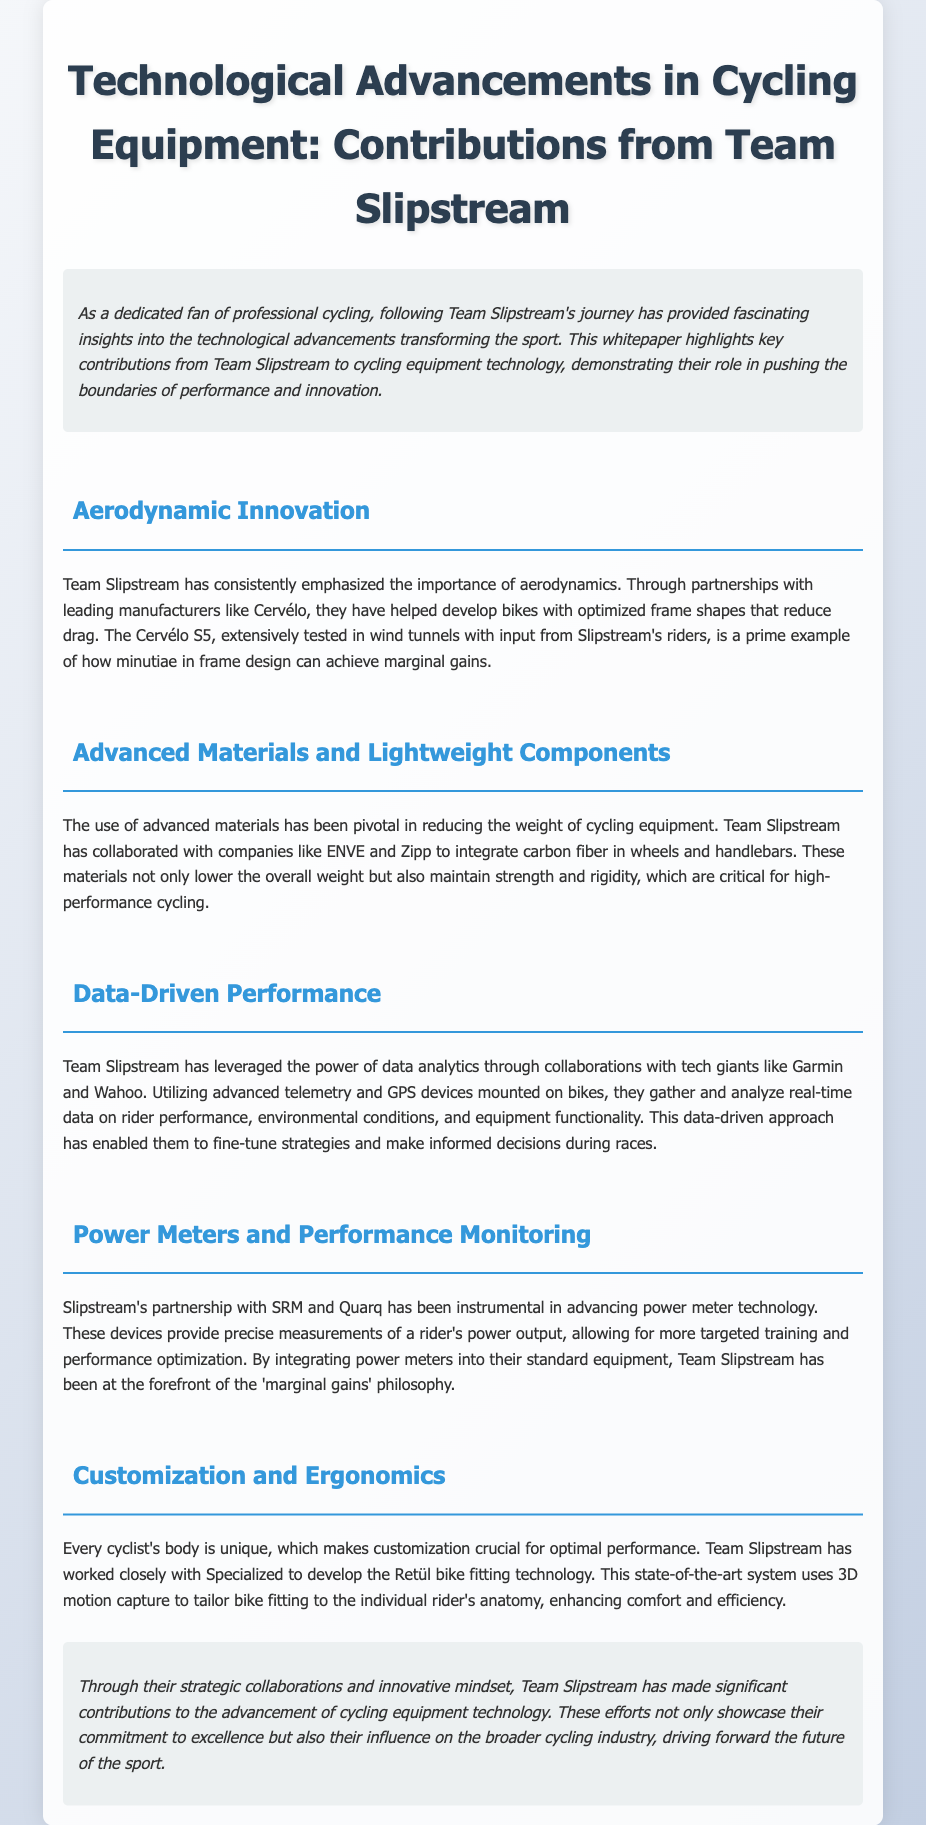what is the title of the whitepaper? The title of the whitepaper is prominently displayed at the top of the document.
Answer: Technological Advancements in Cycling Equipment: Contributions from Team Slipstream who has partnered with Team Slipstream for aerodynamic innovation? The document specifies the manufacturer that collaborated with Team Slipstream for aerodynamic improvements.
Answer: Cervélo which material has Team Slipstream integrated in wheels and handlebars? The document mentions the specific material used in the equipment.
Answer: Carbon fiber what technology does Team Slipstream use for bike fitting? The text describes a specific technology used for customizing bike fits.
Answer: Retül bike fitting technology how has Team Slipstream used data in performance monitoring? The document explains the method by which Team Slipstream analyzes data for performance.
Answer: Advanced telemetry and GPS devices what philosophy has Team Slipstream embraced for performance optimization? The document highlights the approach for enhancing rider performance that the team focuses on.
Answer: Marginal gains which company did Team Slipstream collaborate with for power meter technology? The whitepaper mentions specific companies associated with power meter advancements.
Answer: SRM and Quarq what is a key focus area in the document regarding technological advancements? The document emphasizes various focus areas that contribute to cycling technology.
Answer: Aerodynamics 